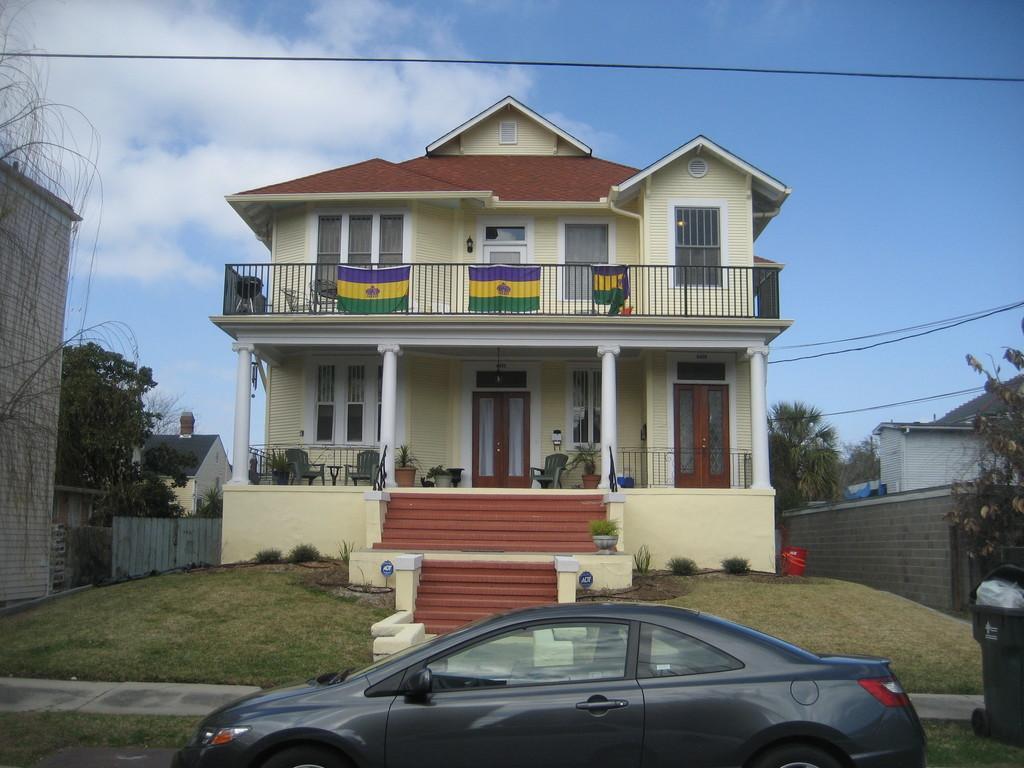In one or two sentences, can you explain what this image depicts? In this picture, we can see a few buildings with windows, doors, pillars, plants in pots, ground with grass, stairs, trees, weirs, road, vehicles, and the sky with clouds. 